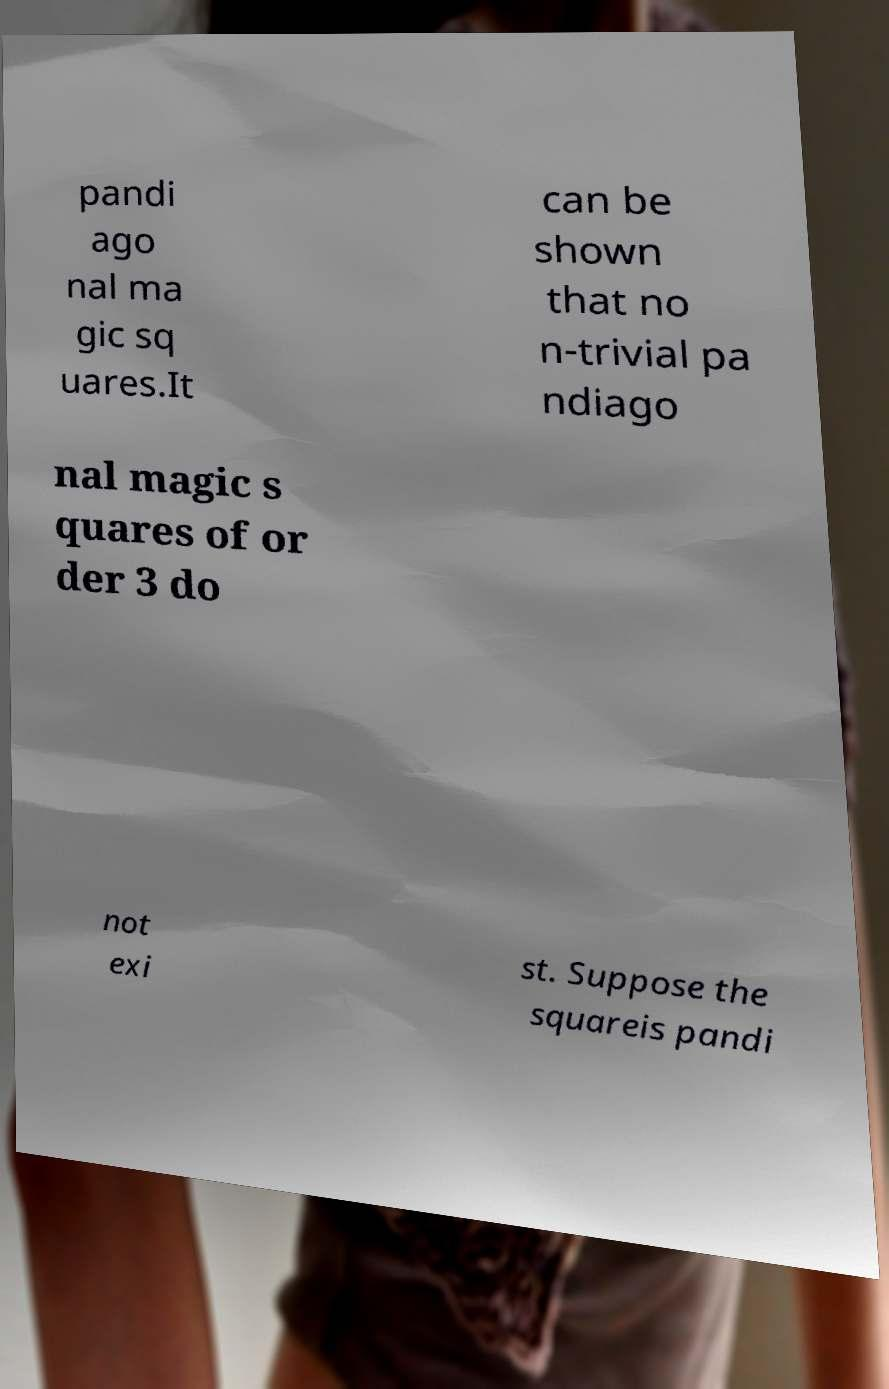There's text embedded in this image that I need extracted. Can you transcribe it verbatim? pandi ago nal ma gic sq uares.It can be shown that no n-trivial pa ndiago nal magic s quares of or der 3 do not exi st. Suppose the squareis pandi 